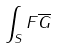Convert formula to latex. <formula><loc_0><loc_0><loc_500><loc_500>\int _ { S } F \overline { G }</formula> 